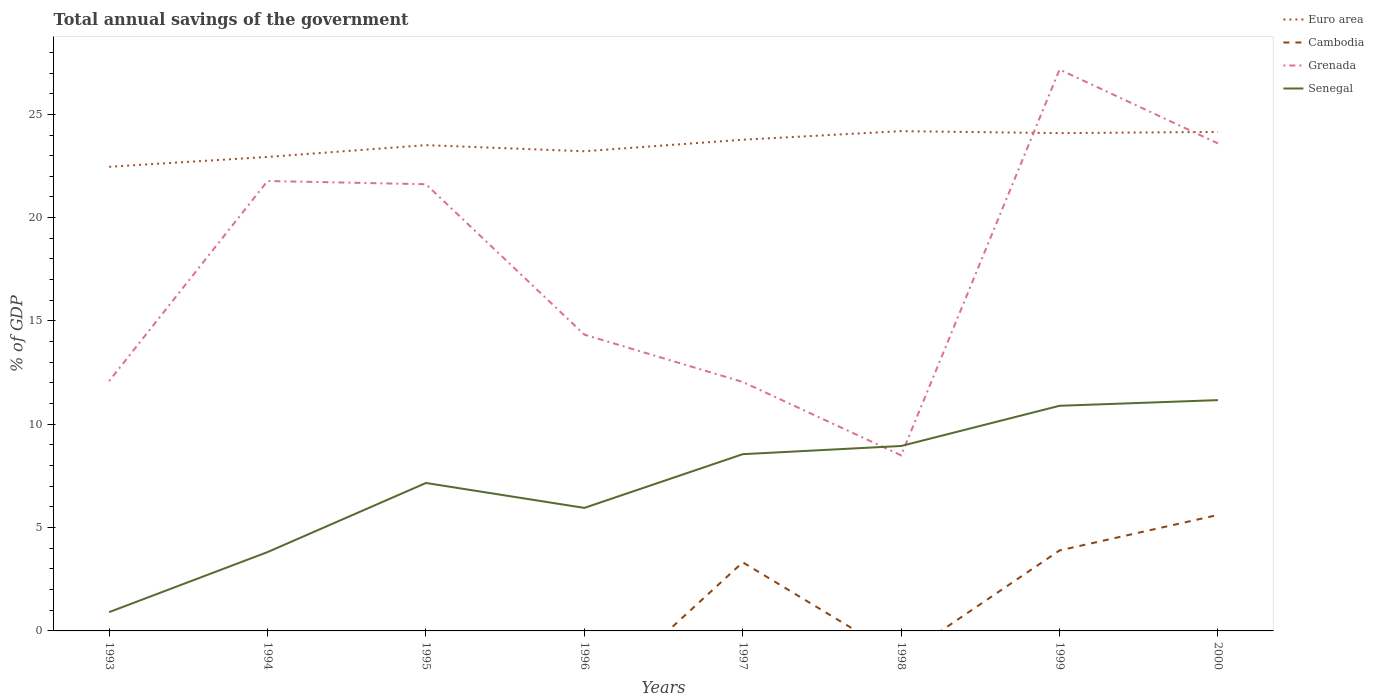How many different coloured lines are there?
Ensure brevity in your answer.  4. Across all years, what is the maximum total annual savings of the government in Cambodia?
Make the answer very short. 0. What is the total total annual savings of the government in Senegal in the graph?
Provide a short and direct response. -2.6. What is the difference between the highest and the second highest total annual savings of the government in Grenada?
Your response must be concise. 18.67. Is the total annual savings of the government in Senegal strictly greater than the total annual savings of the government in Cambodia over the years?
Provide a short and direct response. No. How many lines are there?
Provide a short and direct response. 4. What is the difference between two consecutive major ticks on the Y-axis?
Give a very brief answer. 5. Does the graph contain grids?
Your answer should be compact. No. How are the legend labels stacked?
Keep it short and to the point. Vertical. What is the title of the graph?
Provide a succinct answer. Total annual savings of the government. Does "Arab World" appear as one of the legend labels in the graph?
Your answer should be compact. No. What is the label or title of the X-axis?
Offer a terse response. Years. What is the label or title of the Y-axis?
Offer a very short reply. % of GDP. What is the % of GDP of Euro area in 1993?
Keep it short and to the point. 22.46. What is the % of GDP in Grenada in 1993?
Offer a very short reply. 12.09. What is the % of GDP in Senegal in 1993?
Provide a short and direct response. 0.91. What is the % of GDP of Euro area in 1994?
Offer a very short reply. 22.94. What is the % of GDP in Grenada in 1994?
Keep it short and to the point. 21.77. What is the % of GDP in Senegal in 1994?
Keep it short and to the point. 3.82. What is the % of GDP of Euro area in 1995?
Ensure brevity in your answer.  23.51. What is the % of GDP in Grenada in 1995?
Keep it short and to the point. 21.62. What is the % of GDP of Senegal in 1995?
Your response must be concise. 7.16. What is the % of GDP in Euro area in 1996?
Offer a terse response. 23.21. What is the % of GDP of Grenada in 1996?
Your answer should be compact. 14.34. What is the % of GDP of Senegal in 1996?
Offer a very short reply. 5.95. What is the % of GDP of Euro area in 1997?
Offer a terse response. 23.77. What is the % of GDP of Cambodia in 1997?
Your answer should be very brief. 3.32. What is the % of GDP in Grenada in 1997?
Offer a very short reply. 12.05. What is the % of GDP of Senegal in 1997?
Provide a short and direct response. 8.55. What is the % of GDP in Euro area in 1998?
Provide a succinct answer. 24.19. What is the % of GDP of Grenada in 1998?
Provide a short and direct response. 8.5. What is the % of GDP in Senegal in 1998?
Give a very brief answer. 8.95. What is the % of GDP in Euro area in 1999?
Offer a very short reply. 24.09. What is the % of GDP in Cambodia in 1999?
Keep it short and to the point. 3.9. What is the % of GDP in Grenada in 1999?
Ensure brevity in your answer.  27.17. What is the % of GDP of Senegal in 1999?
Offer a very short reply. 10.9. What is the % of GDP in Euro area in 2000?
Your response must be concise. 24.15. What is the % of GDP in Cambodia in 2000?
Offer a very short reply. 5.61. What is the % of GDP in Grenada in 2000?
Offer a very short reply. 23.59. What is the % of GDP in Senegal in 2000?
Provide a short and direct response. 11.17. Across all years, what is the maximum % of GDP of Euro area?
Provide a succinct answer. 24.19. Across all years, what is the maximum % of GDP in Cambodia?
Make the answer very short. 5.61. Across all years, what is the maximum % of GDP of Grenada?
Ensure brevity in your answer.  27.17. Across all years, what is the maximum % of GDP of Senegal?
Offer a very short reply. 11.17. Across all years, what is the minimum % of GDP of Euro area?
Keep it short and to the point. 22.46. Across all years, what is the minimum % of GDP of Grenada?
Your response must be concise. 8.5. Across all years, what is the minimum % of GDP of Senegal?
Your answer should be very brief. 0.91. What is the total % of GDP in Euro area in the graph?
Your answer should be compact. 188.33. What is the total % of GDP in Cambodia in the graph?
Your answer should be very brief. 12.83. What is the total % of GDP in Grenada in the graph?
Provide a short and direct response. 141.13. What is the total % of GDP of Senegal in the graph?
Keep it short and to the point. 57.41. What is the difference between the % of GDP of Euro area in 1993 and that in 1994?
Provide a succinct answer. -0.48. What is the difference between the % of GDP in Grenada in 1993 and that in 1994?
Ensure brevity in your answer.  -9.68. What is the difference between the % of GDP in Senegal in 1993 and that in 1994?
Offer a terse response. -2.91. What is the difference between the % of GDP in Euro area in 1993 and that in 1995?
Provide a succinct answer. -1.05. What is the difference between the % of GDP of Grenada in 1993 and that in 1995?
Provide a succinct answer. -9.53. What is the difference between the % of GDP in Senegal in 1993 and that in 1995?
Give a very brief answer. -6.25. What is the difference between the % of GDP in Euro area in 1993 and that in 1996?
Offer a very short reply. -0.75. What is the difference between the % of GDP in Grenada in 1993 and that in 1996?
Your response must be concise. -2.25. What is the difference between the % of GDP of Senegal in 1993 and that in 1996?
Ensure brevity in your answer.  -5.04. What is the difference between the % of GDP of Euro area in 1993 and that in 1997?
Provide a short and direct response. -1.31. What is the difference between the % of GDP of Grenada in 1993 and that in 1997?
Provide a short and direct response. 0.04. What is the difference between the % of GDP of Senegal in 1993 and that in 1997?
Provide a short and direct response. -7.64. What is the difference between the % of GDP in Euro area in 1993 and that in 1998?
Your answer should be compact. -1.72. What is the difference between the % of GDP in Grenada in 1993 and that in 1998?
Keep it short and to the point. 3.6. What is the difference between the % of GDP in Senegal in 1993 and that in 1998?
Offer a very short reply. -8.04. What is the difference between the % of GDP in Euro area in 1993 and that in 1999?
Provide a succinct answer. -1.63. What is the difference between the % of GDP of Grenada in 1993 and that in 1999?
Your response must be concise. -15.08. What is the difference between the % of GDP of Senegal in 1993 and that in 1999?
Your answer should be very brief. -9.99. What is the difference between the % of GDP in Euro area in 1993 and that in 2000?
Provide a short and direct response. -1.69. What is the difference between the % of GDP in Grenada in 1993 and that in 2000?
Offer a terse response. -11.5. What is the difference between the % of GDP in Senegal in 1993 and that in 2000?
Provide a short and direct response. -10.26. What is the difference between the % of GDP in Euro area in 1994 and that in 1995?
Offer a terse response. -0.57. What is the difference between the % of GDP of Grenada in 1994 and that in 1995?
Offer a very short reply. 0.16. What is the difference between the % of GDP in Senegal in 1994 and that in 1995?
Keep it short and to the point. -3.34. What is the difference between the % of GDP of Euro area in 1994 and that in 1996?
Your response must be concise. -0.27. What is the difference between the % of GDP in Grenada in 1994 and that in 1996?
Make the answer very short. 7.43. What is the difference between the % of GDP in Senegal in 1994 and that in 1996?
Provide a short and direct response. -2.14. What is the difference between the % of GDP in Euro area in 1994 and that in 1997?
Keep it short and to the point. -0.83. What is the difference between the % of GDP of Grenada in 1994 and that in 1997?
Provide a succinct answer. 9.73. What is the difference between the % of GDP of Senegal in 1994 and that in 1997?
Make the answer very short. -4.74. What is the difference between the % of GDP of Euro area in 1994 and that in 1998?
Offer a very short reply. -1.25. What is the difference between the % of GDP in Grenada in 1994 and that in 1998?
Offer a very short reply. 13.28. What is the difference between the % of GDP in Senegal in 1994 and that in 1998?
Provide a short and direct response. -5.13. What is the difference between the % of GDP in Euro area in 1994 and that in 1999?
Offer a terse response. -1.15. What is the difference between the % of GDP of Grenada in 1994 and that in 1999?
Give a very brief answer. -5.39. What is the difference between the % of GDP in Senegal in 1994 and that in 1999?
Ensure brevity in your answer.  -7.08. What is the difference between the % of GDP in Euro area in 1994 and that in 2000?
Ensure brevity in your answer.  -1.21. What is the difference between the % of GDP in Grenada in 1994 and that in 2000?
Offer a terse response. -1.82. What is the difference between the % of GDP of Senegal in 1994 and that in 2000?
Offer a terse response. -7.35. What is the difference between the % of GDP in Euro area in 1995 and that in 1996?
Make the answer very short. 0.3. What is the difference between the % of GDP in Grenada in 1995 and that in 1996?
Give a very brief answer. 7.28. What is the difference between the % of GDP of Senegal in 1995 and that in 1996?
Offer a very short reply. 1.21. What is the difference between the % of GDP in Euro area in 1995 and that in 1997?
Make the answer very short. -0.26. What is the difference between the % of GDP in Grenada in 1995 and that in 1997?
Provide a succinct answer. 9.57. What is the difference between the % of GDP in Senegal in 1995 and that in 1997?
Offer a terse response. -1.39. What is the difference between the % of GDP of Euro area in 1995 and that in 1998?
Give a very brief answer. -0.68. What is the difference between the % of GDP of Grenada in 1995 and that in 1998?
Provide a succinct answer. 13.12. What is the difference between the % of GDP in Senegal in 1995 and that in 1998?
Your answer should be compact. -1.79. What is the difference between the % of GDP in Euro area in 1995 and that in 1999?
Offer a very short reply. -0.58. What is the difference between the % of GDP in Grenada in 1995 and that in 1999?
Keep it short and to the point. -5.55. What is the difference between the % of GDP of Senegal in 1995 and that in 1999?
Offer a very short reply. -3.74. What is the difference between the % of GDP of Euro area in 1995 and that in 2000?
Your response must be concise. -0.64. What is the difference between the % of GDP in Grenada in 1995 and that in 2000?
Provide a succinct answer. -1.97. What is the difference between the % of GDP in Senegal in 1995 and that in 2000?
Your answer should be compact. -4.01. What is the difference between the % of GDP of Euro area in 1996 and that in 1997?
Provide a succinct answer. -0.56. What is the difference between the % of GDP of Grenada in 1996 and that in 1997?
Your answer should be compact. 2.29. What is the difference between the % of GDP of Senegal in 1996 and that in 1997?
Provide a succinct answer. -2.6. What is the difference between the % of GDP of Euro area in 1996 and that in 1998?
Keep it short and to the point. -0.97. What is the difference between the % of GDP in Grenada in 1996 and that in 1998?
Your response must be concise. 5.84. What is the difference between the % of GDP in Senegal in 1996 and that in 1998?
Provide a short and direct response. -3. What is the difference between the % of GDP in Euro area in 1996 and that in 1999?
Your answer should be very brief. -0.88. What is the difference between the % of GDP of Grenada in 1996 and that in 1999?
Your answer should be very brief. -12.83. What is the difference between the % of GDP of Senegal in 1996 and that in 1999?
Keep it short and to the point. -4.94. What is the difference between the % of GDP of Euro area in 1996 and that in 2000?
Make the answer very short. -0.94. What is the difference between the % of GDP of Grenada in 1996 and that in 2000?
Ensure brevity in your answer.  -9.25. What is the difference between the % of GDP in Senegal in 1996 and that in 2000?
Provide a short and direct response. -5.22. What is the difference between the % of GDP in Euro area in 1997 and that in 1998?
Your answer should be very brief. -0.42. What is the difference between the % of GDP of Grenada in 1997 and that in 1998?
Offer a very short reply. 3.55. What is the difference between the % of GDP of Senegal in 1997 and that in 1998?
Your answer should be very brief. -0.4. What is the difference between the % of GDP in Euro area in 1997 and that in 1999?
Your answer should be very brief. -0.32. What is the difference between the % of GDP of Cambodia in 1997 and that in 1999?
Provide a succinct answer. -0.58. What is the difference between the % of GDP in Grenada in 1997 and that in 1999?
Your answer should be compact. -15.12. What is the difference between the % of GDP in Senegal in 1997 and that in 1999?
Provide a short and direct response. -2.34. What is the difference between the % of GDP in Euro area in 1997 and that in 2000?
Offer a terse response. -0.38. What is the difference between the % of GDP of Cambodia in 1997 and that in 2000?
Provide a succinct answer. -2.29. What is the difference between the % of GDP of Grenada in 1997 and that in 2000?
Keep it short and to the point. -11.54. What is the difference between the % of GDP of Senegal in 1997 and that in 2000?
Offer a terse response. -2.62. What is the difference between the % of GDP in Euro area in 1998 and that in 1999?
Provide a short and direct response. 0.1. What is the difference between the % of GDP in Grenada in 1998 and that in 1999?
Offer a very short reply. -18.67. What is the difference between the % of GDP of Senegal in 1998 and that in 1999?
Make the answer very short. -1.95. What is the difference between the % of GDP of Euro area in 1998 and that in 2000?
Offer a terse response. 0.04. What is the difference between the % of GDP in Grenada in 1998 and that in 2000?
Your response must be concise. -15.1. What is the difference between the % of GDP in Senegal in 1998 and that in 2000?
Offer a terse response. -2.22. What is the difference between the % of GDP of Euro area in 1999 and that in 2000?
Give a very brief answer. -0.06. What is the difference between the % of GDP of Cambodia in 1999 and that in 2000?
Ensure brevity in your answer.  -1.72. What is the difference between the % of GDP of Grenada in 1999 and that in 2000?
Provide a short and direct response. 3.58. What is the difference between the % of GDP in Senegal in 1999 and that in 2000?
Your response must be concise. -0.27. What is the difference between the % of GDP of Euro area in 1993 and the % of GDP of Grenada in 1994?
Ensure brevity in your answer.  0.69. What is the difference between the % of GDP of Euro area in 1993 and the % of GDP of Senegal in 1994?
Give a very brief answer. 18.65. What is the difference between the % of GDP in Grenada in 1993 and the % of GDP in Senegal in 1994?
Make the answer very short. 8.28. What is the difference between the % of GDP in Euro area in 1993 and the % of GDP in Grenada in 1995?
Ensure brevity in your answer.  0.84. What is the difference between the % of GDP in Euro area in 1993 and the % of GDP in Senegal in 1995?
Provide a short and direct response. 15.3. What is the difference between the % of GDP of Grenada in 1993 and the % of GDP of Senegal in 1995?
Your answer should be very brief. 4.93. What is the difference between the % of GDP in Euro area in 1993 and the % of GDP in Grenada in 1996?
Provide a short and direct response. 8.12. What is the difference between the % of GDP of Euro area in 1993 and the % of GDP of Senegal in 1996?
Ensure brevity in your answer.  16.51. What is the difference between the % of GDP in Grenada in 1993 and the % of GDP in Senegal in 1996?
Make the answer very short. 6.14. What is the difference between the % of GDP in Euro area in 1993 and the % of GDP in Cambodia in 1997?
Give a very brief answer. 19.14. What is the difference between the % of GDP of Euro area in 1993 and the % of GDP of Grenada in 1997?
Give a very brief answer. 10.41. What is the difference between the % of GDP of Euro area in 1993 and the % of GDP of Senegal in 1997?
Provide a short and direct response. 13.91. What is the difference between the % of GDP in Grenada in 1993 and the % of GDP in Senegal in 1997?
Ensure brevity in your answer.  3.54. What is the difference between the % of GDP in Euro area in 1993 and the % of GDP in Grenada in 1998?
Make the answer very short. 13.97. What is the difference between the % of GDP of Euro area in 1993 and the % of GDP of Senegal in 1998?
Ensure brevity in your answer.  13.51. What is the difference between the % of GDP of Grenada in 1993 and the % of GDP of Senegal in 1998?
Your response must be concise. 3.14. What is the difference between the % of GDP of Euro area in 1993 and the % of GDP of Cambodia in 1999?
Provide a short and direct response. 18.57. What is the difference between the % of GDP in Euro area in 1993 and the % of GDP in Grenada in 1999?
Provide a succinct answer. -4.71. What is the difference between the % of GDP in Euro area in 1993 and the % of GDP in Senegal in 1999?
Keep it short and to the point. 11.57. What is the difference between the % of GDP in Grenada in 1993 and the % of GDP in Senegal in 1999?
Make the answer very short. 1.2. What is the difference between the % of GDP in Euro area in 1993 and the % of GDP in Cambodia in 2000?
Make the answer very short. 16.85. What is the difference between the % of GDP in Euro area in 1993 and the % of GDP in Grenada in 2000?
Ensure brevity in your answer.  -1.13. What is the difference between the % of GDP of Euro area in 1993 and the % of GDP of Senegal in 2000?
Make the answer very short. 11.29. What is the difference between the % of GDP in Grenada in 1993 and the % of GDP in Senegal in 2000?
Offer a very short reply. 0.92. What is the difference between the % of GDP of Euro area in 1994 and the % of GDP of Grenada in 1995?
Offer a terse response. 1.32. What is the difference between the % of GDP of Euro area in 1994 and the % of GDP of Senegal in 1995?
Your answer should be very brief. 15.78. What is the difference between the % of GDP of Grenada in 1994 and the % of GDP of Senegal in 1995?
Give a very brief answer. 14.61. What is the difference between the % of GDP in Euro area in 1994 and the % of GDP in Grenada in 1996?
Offer a terse response. 8.6. What is the difference between the % of GDP of Euro area in 1994 and the % of GDP of Senegal in 1996?
Your answer should be very brief. 16.99. What is the difference between the % of GDP of Grenada in 1994 and the % of GDP of Senegal in 1996?
Give a very brief answer. 15.82. What is the difference between the % of GDP of Euro area in 1994 and the % of GDP of Cambodia in 1997?
Your response must be concise. 19.62. What is the difference between the % of GDP of Euro area in 1994 and the % of GDP of Grenada in 1997?
Provide a short and direct response. 10.89. What is the difference between the % of GDP of Euro area in 1994 and the % of GDP of Senegal in 1997?
Offer a very short reply. 14.39. What is the difference between the % of GDP of Grenada in 1994 and the % of GDP of Senegal in 1997?
Keep it short and to the point. 13.22. What is the difference between the % of GDP of Euro area in 1994 and the % of GDP of Grenada in 1998?
Provide a succinct answer. 14.44. What is the difference between the % of GDP of Euro area in 1994 and the % of GDP of Senegal in 1998?
Your response must be concise. 13.99. What is the difference between the % of GDP of Grenada in 1994 and the % of GDP of Senegal in 1998?
Make the answer very short. 12.82. What is the difference between the % of GDP in Euro area in 1994 and the % of GDP in Cambodia in 1999?
Your response must be concise. 19.04. What is the difference between the % of GDP of Euro area in 1994 and the % of GDP of Grenada in 1999?
Offer a terse response. -4.23. What is the difference between the % of GDP of Euro area in 1994 and the % of GDP of Senegal in 1999?
Your response must be concise. 12.04. What is the difference between the % of GDP of Grenada in 1994 and the % of GDP of Senegal in 1999?
Your answer should be compact. 10.88. What is the difference between the % of GDP of Euro area in 1994 and the % of GDP of Cambodia in 2000?
Offer a terse response. 17.33. What is the difference between the % of GDP of Euro area in 1994 and the % of GDP of Grenada in 2000?
Provide a short and direct response. -0.65. What is the difference between the % of GDP in Euro area in 1994 and the % of GDP in Senegal in 2000?
Offer a terse response. 11.77. What is the difference between the % of GDP of Grenada in 1994 and the % of GDP of Senegal in 2000?
Offer a terse response. 10.6. What is the difference between the % of GDP of Euro area in 1995 and the % of GDP of Grenada in 1996?
Your answer should be very brief. 9.17. What is the difference between the % of GDP of Euro area in 1995 and the % of GDP of Senegal in 1996?
Give a very brief answer. 17.56. What is the difference between the % of GDP of Grenada in 1995 and the % of GDP of Senegal in 1996?
Keep it short and to the point. 15.66. What is the difference between the % of GDP of Euro area in 1995 and the % of GDP of Cambodia in 1997?
Give a very brief answer. 20.19. What is the difference between the % of GDP in Euro area in 1995 and the % of GDP in Grenada in 1997?
Give a very brief answer. 11.46. What is the difference between the % of GDP of Euro area in 1995 and the % of GDP of Senegal in 1997?
Give a very brief answer. 14.96. What is the difference between the % of GDP of Grenada in 1995 and the % of GDP of Senegal in 1997?
Your answer should be compact. 13.06. What is the difference between the % of GDP of Euro area in 1995 and the % of GDP of Grenada in 1998?
Your answer should be very brief. 15.01. What is the difference between the % of GDP in Euro area in 1995 and the % of GDP in Senegal in 1998?
Provide a short and direct response. 14.56. What is the difference between the % of GDP in Grenada in 1995 and the % of GDP in Senegal in 1998?
Your answer should be very brief. 12.67. What is the difference between the % of GDP in Euro area in 1995 and the % of GDP in Cambodia in 1999?
Provide a succinct answer. 19.61. What is the difference between the % of GDP in Euro area in 1995 and the % of GDP in Grenada in 1999?
Offer a terse response. -3.66. What is the difference between the % of GDP in Euro area in 1995 and the % of GDP in Senegal in 1999?
Your answer should be very brief. 12.61. What is the difference between the % of GDP of Grenada in 1995 and the % of GDP of Senegal in 1999?
Keep it short and to the point. 10.72. What is the difference between the % of GDP of Euro area in 1995 and the % of GDP of Cambodia in 2000?
Your response must be concise. 17.9. What is the difference between the % of GDP in Euro area in 1995 and the % of GDP in Grenada in 2000?
Give a very brief answer. -0.08. What is the difference between the % of GDP in Euro area in 1995 and the % of GDP in Senegal in 2000?
Keep it short and to the point. 12.34. What is the difference between the % of GDP in Grenada in 1995 and the % of GDP in Senegal in 2000?
Provide a succinct answer. 10.45. What is the difference between the % of GDP in Euro area in 1996 and the % of GDP in Cambodia in 1997?
Ensure brevity in your answer.  19.89. What is the difference between the % of GDP in Euro area in 1996 and the % of GDP in Grenada in 1997?
Your answer should be compact. 11.17. What is the difference between the % of GDP in Euro area in 1996 and the % of GDP in Senegal in 1997?
Make the answer very short. 14.66. What is the difference between the % of GDP of Grenada in 1996 and the % of GDP of Senegal in 1997?
Ensure brevity in your answer.  5.79. What is the difference between the % of GDP in Euro area in 1996 and the % of GDP in Grenada in 1998?
Give a very brief answer. 14.72. What is the difference between the % of GDP of Euro area in 1996 and the % of GDP of Senegal in 1998?
Provide a short and direct response. 14.26. What is the difference between the % of GDP in Grenada in 1996 and the % of GDP in Senegal in 1998?
Make the answer very short. 5.39. What is the difference between the % of GDP of Euro area in 1996 and the % of GDP of Cambodia in 1999?
Offer a terse response. 19.32. What is the difference between the % of GDP in Euro area in 1996 and the % of GDP in Grenada in 1999?
Provide a succinct answer. -3.96. What is the difference between the % of GDP of Euro area in 1996 and the % of GDP of Senegal in 1999?
Offer a very short reply. 12.32. What is the difference between the % of GDP of Grenada in 1996 and the % of GDP of Senegal in 1999?
Ensure brevity in your answer.  3.44. What is the difference between the % of GDP of Euro area in 1996 and the % of GDP of Cambodia in 2000?
Offer a very short reply. 17.6. What is the difference between the % of GDP in Euro area in 1996 and the % of GDP in Grenada in 2000?
Provide a succinct answer. -0.38. What is the difference between the % of GDP of Euro area in 1996 and the % of GDP of Senegal in 2000?
Ensure brevity in your answer.  12.04. What is the difference between the % of GDP in Grenada in 1996 and the % of GDP in Senegal in 2000?
Offer a very short reply. 3.17. What is the difference between the % of GDP of Euro area in 1997 and the % of GDP of Grenada in 1998?
Provide a succinct answer. 15.27. What is the difference between the % of GDP of Euro area in 1997 and the % of GDP of Senegal in 1998?
Your answer should be very brief. 14.82. What is the difference between the % of GDP of Cambodia in 1997 and the % of GDP of Grenada in 1998?
Provide a short and direct response. -5.18. What is the difference between the % of GDP of Cambodia in 1997 and the % of GDP of Senegal in 1998?
Provide a succinct answer. -5.63. What is the difference between the % of GDP in Grenada in 1997 and the % of GDP in Senegal in 1998?
Offer a very short reply. 3.1. What is the difference between the % of GDP in Euro area in 1997 and the % of GDP in Cambodia in 1999?
Ensure brevity in your answer.  19.88. What is the difference between the % of GDP in Euro area in 1997 and the % of GDP in Grenada in 1999?
Offer a terse response. -3.4. What is the difference between the % of GDP of Euro area in 1997 and the % of GDP of Senegal in 1999?
Ensure brevity in your answer.  12.88. What is the difference between the % of GDP in Cambodia in 1997 and the % of GDP in Grenada in 1999?
Give a very brief answer. -23.85. What is the difference between the % of GDP of Cambodia in 1997 and the % of GDP of Senegal in 1999?
Provide a short and direct response. -7.58. What is the difference between the % of GDP of Grenada in 1997 and the % of GDP of Senegal in 1999?
Provide a short and direct response. 1.15. What is the difference between the % of GDP of Euro area in 1997 and the % of GDP of Cambodia in 2000?
Give a very brief answer. 18.16. What is the difference between the % of GDP in Euro area in 1997 and the % of GDP in Grenada in 2000?
Offer a very short reply. 0.18. What is the difference between the % of GDP in Euro area in 1997 and the % of GDP in Senegal in 2000?
Keep it short and to the point. 12.6. What is the difference between the % of GDP in Cambodia in 1997 and the % of GDP in Grenada in 2000?
Provide a short and direct response. -20.27. What is the difference between the % of GDP of Cambodia in 1997 and the % of GDP of Senegal in 2000?
Your answer should be compact. -7.85. What is the difference between the % of GDP of Grenada in 1997 and the % of GDP of Senegal in 2000?
Keep it short and to the point. 0.88. What is the difference between the % of GDP of Euro area in 1998 and the % of GDP of Cambodia in 1999?
Your response must be concise. 20.29. What is the difference between the % of GDP of Euro area in 1998 and the % of GDP of Grenada in 1999?
Your answer should be compact. -2.98. What is the difference between the % of GDP in Euro area in 1998 and the % of GDP in Senegal in 1999?
Provide a succinct answer. 13.29. What is the difference between the % of GDP in Grenada in 1998 and the % of GDP in Senegal in 1999?
Offer a very short reply. -2.4. What is the difference between the % of GDP in Euro area in 1998 and the % of GDP in Cambodia in 2000?
Keep it short and to the point. 18.58. What is the difference between the % of GDP in Euro area in 1998 and the % of GDP in Grenada in 2000?
Make the answer very short. 0.59. What is the difference between the % of GDP of Euro area in 1998 and the % of GDP of Senegal in 2000?
Your answer should be very brief. 13.02. What is the difference between the % of GDP in Grenada in 1998 and the % of GDP in Senegal in 2000?
Your response must be concise. -2.67. What is the difference between the % of GDP in Euro area in 1999 and the % of GDP in Cambodia in 2000?
Make the answer very short. 18.48. What is the difference between the % of GDP in Euro area in 1999 and the % of GDP in Grenada in 2000?
Offer a very short reply. 0.5. What is the difference between the % of GDP of Euro area in 1999 and the % of GDP of Senegal in 2000?
Ensure brevity in your answer.  12.92. What is the difference between the % of GDP of Cambodia in 1999 and the % of GDP of Grenada in 2000?
Your answer should be very brief. -19.7. What is the difference between the % of GDP of Cambodia in 1999 and the % of GDP of Senegal in 2000?
Give a very brief answer. -7.27. What is the difference between the % of GDP in Grenada in 1999 and the % of GDP in Senegal in 2000?
Provide a short and direct response. 16. What is the average % of GDP of Euro area per year?
Keep it short and to the point. 23.54. What is the average % of GDP of Cambodia per year?
Make the answer very short. 1.6. What is the average % of GDP of Grenada per year?
Provide a short and direct response. 17.64. What is the average % of GDP in Senegal per year?
Provide a succinct answer. 7.18. In the year 1993, what is the difference between the % of GDP of Euro area and % of GDP of Grenada?
Ensure brevity in your answer.  10.37. In the year 1993, what is the difference between the % of GDP in Euro area and % of GDP in Senegal?
Keep it short and to the point. 21.55. In the year 1993, what is the difference between the % of GDP in Grenada and % of GDP in Senegal?
Your answer should be compact. 11.18. In the year 1994, what is the difference between the % of GDP in Euro area and % of GDP in Grenada?
Provide a short and direct response. 1.17. In the year 1994, what is the difference between the % of GDP in Euro area and % of GDP in Senegal?
Keep it short and to the point. 19.12. In the year 1994, what is the difference between the % of GDP in Grenada and % of GDP in Senegal?
Your answer should be very brief. 17.96. In the year 1995, what is the difference between the % of GDP of Euro area and % of GDP of Grenada?
Provide a succinct answer. 1.89. In the year 1995, what is the difference between the % of GDP in Euro area and % of GDP in Senegal?
Give a very brief answer. 16.35. In the year 1995, what is the difference between the % of GDP of Grenada and % of GDP of Senegal?
Your answer should be compact. 14.46. In the year 1996, what is the difference between the % of GDP in Euro area and % of GDP in Grenada?
Provide a succinct answer. 8.87. In the year 1996, what is the difference between the % of GDP of Euro area and % of GDP of Senegal?
Give a very brief answer. 17.26. In the year 1996, what is the difference between the % of GDP of Grenada and % of GDP of Senegal?
Provide a succinct answer. 8.39. In the year 1997, what is the difference between the % of GDP of Euro area and % of GDP of Cambodia?
Offer a very short reply. 20.45. In the year 1997, what is the difference between the % of GDP in Euro area and % of GDP in Grenada?
Offer a terse response. 11.72. In the year 1997, what is the difference between the % of GDP in Euro area and % of GDP in Senegal?
Your answer should be compact. 15.22. In the year 1997, what is the difference between the % of GDP of Cambodia and % of GDP of Grenada?
Offer a terse response. -8.73. In the year 1997, what is the difference between the % of GDP in Cambodia and % of GDP in Senegal?
Keep it short and to the point. -5.23. In the year 1997, what is the difference between the % of GDP in Grenada and % of GDP in Senegal?
Keep it short and to the point. 3.5. In the year 1998, what is the difference between the % of GDP of Euro area and % of GDP of Grenada?
Keep it short and to the point. 15.69. In the year 1998, what is the difference between the % of GDP in Euro area and % of GDP in Senegal?
Provide a succinct answer. 15.24. In the year 1998, what is the difference between the % of GDP of Grenada and % of GDP of Senegal?
Make the answer very short. -0.45. In the year 1999, what is the difference between the % of GDP of Euro area and % of GDP of Cambodia?
Give a very brief answer. 20.2. In the year 1999, what is the difference between the % of GDP in Euro area and % of GDP in Grenada?
Your response must be concise. -3.08. In the year 1999, what is the difference between the % of GDP of Euro area and % of GDP of Senegal?
Offer a terse response. 13.2. In the year 1999, what is the difference between the % of GDP in Cambodia and % of GDP in Grenada?
Make the answer very short. -23.27. In the year 1999, what is the difference between the % of GDP of Cambodia and % of GDP of Senegal?
Ensure brevity in your answer.  -7. In the year 1999, what is the difference between the % of GDP in Grenada and % of GDP in Senegal?
Your response must be concise. 16.27. In the year 2000, what is the difference between the % of GDP in Euro area and % of GDP in Cambodia?
Give a very brief answer. 18.54. In the year 2000, what is the difference between the % of GDP in Euro area and % of GDP in Grenada?
Your response must be concise. 0.56. In the year 2000, what is the difference between the % of GDP of Euro area and % of GDP of Senegal?
Provide a succinct answer. 12.98. In the year 2000, what is the difference between the % of GDP of Cambodia and % of GDP of Grenada?
Keep it short and to the point. -17.98. In the year 2000, what is the difference between the % of GDP in Cambodia and % of GDP in Senegal?
Offer a very short reply. -5.56. In the year 2000, what is the difference between the % of GDP in Grenada and % of GDP in Senegal?
Make the answer very short. 12.42. What is the ratio of the % of GDP in Euro area in 1993 to that in 1994?
Make the answer very short. 0.98. What is the ratio of the % of GDP in Grenada in 1993 to that in 1994?
Offer a terse response. 0.56. What is the ratio of the % of GDP in Senegal in 1993 to that in 1994?
Your answer should be very brief. 0.24. What is the ratio of the % of GDP in Euro area in 1993 to that in 1995?
Your response must be concise. 0.96. What is the ratio of the % of GDP in Grenada in 1993 to that in 1995?
Keep it short and to the point. 0.56. What is the ratio of the % of GDP in Senegal in 1993 to that in 1995?
Make the answer very short. 0.13. What is the ratio of the % of GDP of Euro area in 1993 to that in 1996?
Provide a succinct answer. 0.97. What is the ratio of the % of GDP of Grenada in 1993 to that in 1996?
Give a very brief answer. 0.84. What is the ratio of the % of GDP in Senegal in 1993 to that in 1996?
Your answer should be compact. 0.15. What is the ratio of the % of GDP of Euro area in 1993 to that in 1997?
Provide a short and direct response. 0.94. What is the ratio of the % of GDP in Grenada in 1993 to that in 1997?
Your answer should be compact. 1. What is the ratio of the % of GDP of Senegal in 1993 to that in 1997?
Your answer should be very brief. 0.11. What is the ratio of the % of GDP in Euro area in 1993 to that in 1998?
Ensure brevity in your answer.  0.93. What is the ratio of the % of GDP of Grenada in 1993 to that in 1998?
Give a very brief answer. 1.42. What is the ratio of the % of GDP of Senegal in 1993 to that in 1998?
Give a very brief answer. 0.1. What is the ratio of the % of GDP in Euro area in 1993 to that in 1999?
Your answer should be very brief. 0.93. What is the ratio of the % of GDP of Grenada in 1993 to that in 1999?
Ensure brevity in your answer.  0.45. What is the ratio of the % of GDP in Senegal in 1993 to that in 1999?
Provide a short and direct response. 0.08. What is the ratio of the % of GDP of Euro area in 1993 to that in 2000?
Make the answer very short. 0.93. What is the ratio of the % of GDP in Grenada in 1993 to that in 2000?
Offer a terse response. 0.51. What is the ratio of the % of GDP of Senegal in 1993 to that in 2000?
Give a very brief answer. 0.08. What is the ratio of the % of GDP of Euro area in 1994 to that in 1995?
Your answer should be compact. 0.98. What is the ratio of the % of GDP in Grenada in 1994 to that in 1995?
Ensure brevity in your answer.  1.01. What is the ratio of the % of GDP of Senegal in 1994 to that in 1995?
Offer a very short reply. 0.53. What is the ratio of the % of GDP in Euro area in 1994 to that in 1996?
Provide a succinct answer. 0.99. What is the ratio of the % of GDP in Grenada in 1994 to that in 1996?
Your answer should be very brief. 1.52. What is the ratio of the % of GDP of Senegal in 1994 to that in 1996?
Make the answer very short. 0.64. What is the ratio of the % of GDP in Euro area in 1994 to that in 1997?
Offer a very short reply. 0.96. What is the ratio of the % of GDP of Grenada in 1994 to that in 1997?
Provide a succinct answer. 1.81. What is the ratio of the % of GDP in Senegal in 1994 to that in 1997?
Your answer should be very brief. 0.45. What is the ratio of the % of GDP of Euro area in 1994 to that in 1998?
Make the answer very short. 0.95. What is the ratio of the % of GDP in Grenada in 1994 to that in 1998?
Ensure brevity in your answer.  2.56. What is the ratio of the % of GDP in Senegal in 1994 to that in 1998?
Make the answer very short. 0.43. What is the ratio of the % of GDP of Euro area in 1994 to that in 1999?
Provide a short and direct response. 0.95. What is the ratio of the % of GDP in Grenada in 1994 to that in 1999?
Make the answer very short. 0.8. What is the ratio of the % of GDP in Senegal in 1994 to that in 1999?
Provide a short and direct response. 0.35. What is the ratio of the % of GDP of Euro area in 1994 to that in 2000?
Provide a short and direct response. 0.95. What is the ratio of the % of GDP of Grenada in 1994 to that in 2000?
Offer a very short reply. 0.92. What is the ratio of the % of GDP in Senegal in 1994 to that in 2000?
Keep it short and to the point. 0.34. What is the ratio of the % of GDP of Euro area in 1995 to that in 1996?
Offer a very short reply. 1.01. What is the ratio of the % of GDP in Grenada in 1995 to that in 1996?
Provide a succinct answer. 1.51. What is the ratio of the % of GDP in Senegal in 1995 to that in 1996?
Your response must be concise. 1.2. What is the ratio of the % of GDP of Euro area in 1995 to that in 1997?
Offer a very short reply. 0.99. What is the ratio of the % of GDP of Grenada in 1995 to that in 1997?
Offer a terse response. 1.79. What is the ratio of the % of GDP of Senegal in 1995 to that in 1997?
Offer a very short reply. 0.84. What is the ratio of the % of GDP of Euro area in 1995 to that in 1998?
Your response must be concise. 0.97. What is the ratio of the % of GDP in Grenada in 1995 to that in 1998?
Give a very brief answer. 2.54. What is the ratio of the % of GDP of Senegal in 1995 to that in 1998?
Offer a terse response. 0.8. What is the ratio of the % of GDP in Euro area in 1995 to that in 1999?
Your response must be concise. 0.98. What is the ratio of the % of GDP of Grenada in 1995 to that in 1999?
Provide a short and direct response. 0.8. What is the ratio of the % of GDP of Senegal in 1995 to that in 1999?
Give a very brief answer. 0.66. What is the ratio of the % of GDP of Euro area in 1995 to that in 2000?
Your answer should be compact. 0.97. What is the ratio of the % of GDP in Grenada in 1995 to that in 2000?
Give a very brief answer. 0.92. What is the ratio of the % of GDP in Senegal in 1995 to that in 2000?
Your answer should be compact. 0.64. What is the ratio of the % of GDP of Euro area in 1996 to that in 1997?
Offer a terse response. 0.98. What is the ratio of the % of GDP in Grenada in 1996 to that in 1997?
Your answer should be compact. 1.19. What is the ratio of the % of GDP of Senegal in 1996 to that in 1997?
Your answer should be compact. 0.7. What is the ratio of the % of GDP of Euro area in 1996 to that in 1998?
Provide a succinct answer. 0.96. What is the ratio of the % of GDP of Grenada in 1996 to that in 1998?
Ensure brevity in your answer.  1.69. What is the ratio of the % of GDP in Senegal in 1996 to that in 1998?
Give a very brief answer. 0.67. What is the ratio of the % of GDP of Euro area in 1996 to that in 1999?
Keep it short and to the point. 0.96. What is the ratio of the % of GDP in Grenada in 1996 to that in 1999?
Give a very brief answer. 0.53. What is the ratio of the % of GDP in Senegal in 1996 to that in 1999?
Give a very brief answer. 0.55. What is the ratio of the % of GDP of Euro area in 1996 to that in 2000?
Give a very brief answer. 0.96. What is the ratio of the % of GDP in Grenada in 1996 to that in 2000?
Keep it short and to the point. 0.61. What is the ratio of the % of GDP in Senegal in 1996 to that in 2000?
Your response must be concise. 0.53. What is the ratio of the % of GDP in Euro area in 1997 to that in 1998?
Your answer should be very brief. 0.98. What is the ratio of the % of GDP in Grenada in 1997 to that in 1998?
Offer a terse response. 1.42. What is the ratio of the % of GDP in Senegal in 1997 to that in 1998?
Ensure brevity in your answer.  0.96. What is the ratio of the % of GDP in Euro area in 1997 to that in 1999?
Your answer should be very brief. 0.99. What is the ratio of the % of GDP of Cambodia in 1997 to that in 1999?
Your answer should be compact. 0.85. What is the ratio of the % of GDP in Grenada in 1997 to that in 1999?
Provide a short and direct response. 0.44. What is the ratio of the % of GDP of Senegal in 1997 to that in 1999?
Offer a very short reply. 0.79. What is the ratio of the % of GDP in Euro area in 1997 to that in 2000?
Keep it short and to the point. 0.98. What is the ratio of the % of GDP in Cambodia in 1997 to that in 2000?
Provide a succinct answer. 0.59. What is the ratio of the % of GDP in Grenada in 1997 to that in 2000?
Your answer should be compact. 0.51. What is the ratio of the % of GDP in Senegal in 1997 to that in 2000?
Provide a succinct answer. 0.77. What is the ratio of the % of GDP of Grenada in 1998 to that in 1999?
Give a very brief answer. 0.31. What is the ratio of the % of GDP of Senegal in 1998 to that in 1999?
Ensure brevity in your answer.  0.82. What is the ratio of the % of GDP in Euro area in 1998 to that in 2000?
Make the answer very short. 1. What is the ratio of the % of GDP in Grenada in 1998 to that in 2000?
Give a very brief answer. 0.36. What is the ratio of the % of GDP in Senegal in 1998 to that in 2000?
Ensure brevity in your answer.  0.8. What is the ratio of the % of GDP of Euro area in 1999 to that in 2000?
Your response must be concise. 1. What is the ratio of the % of GDP of Cambodia in 1999 to that in 2000?
Your answer should be compact. 0.69. What is the ratio of the % of GDP in Grenada in 1999 to that in 2000?
Ensure brevity in your answer.  1.15. What is the ratio of the % of GDP of Senegal in 1999 to that in 2000?
Offer a terse response. 0.98. What is the difference between the highest and the second highest % of GDP of Euro area?
Give a very brief answer. 0.04. What is the difference between the highest and the second highest % of GDP of Cambodia?
Keep it short and to the point. 1.72. What is the difference between the highest and the second highest % of GDP in Grenada?
Offer a very short reply. 3.58. What is the difference between the highest and the second highest % of GDP in Senegal?
Ensure brevity in your answer.  0.27. What is the difference between the highest and the lowest % of GDP in Euro area?
Offer a very short reply. 1.72. What is the difference between the highest and the lowest % of GDP of Cambodia?
Offer a terse response. 5.61. What is the difference between the highest and the lowest % of GDP of Grenada?
Your answer should be compact. 18.67. What is the difference between the highest and the lowest % of GDP of Senegal?
Your answer should be compact. 10.26. 